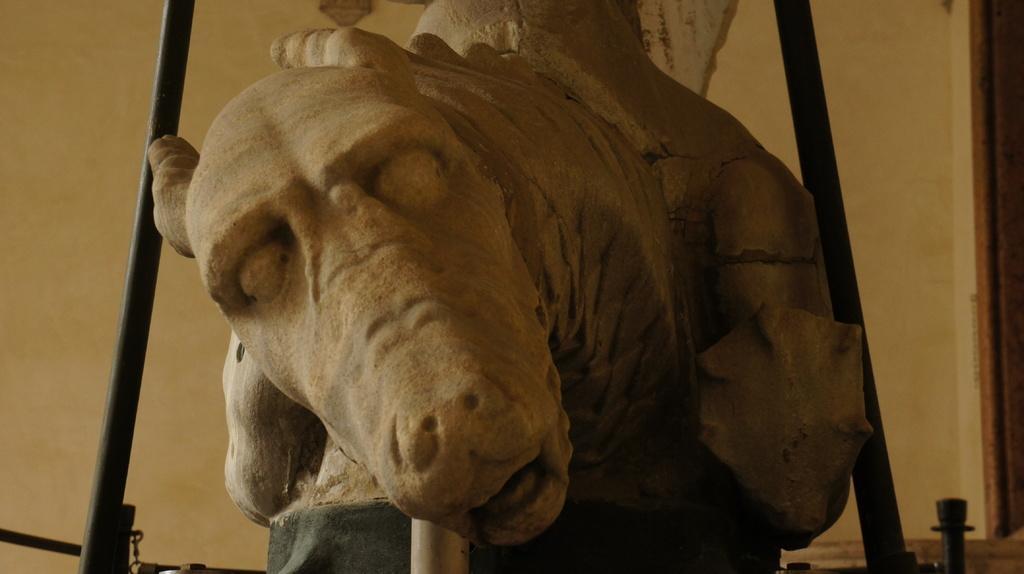How would you summarize this image in a sentence or two? In the image we can see a statue. Behind the statue there is wall. 